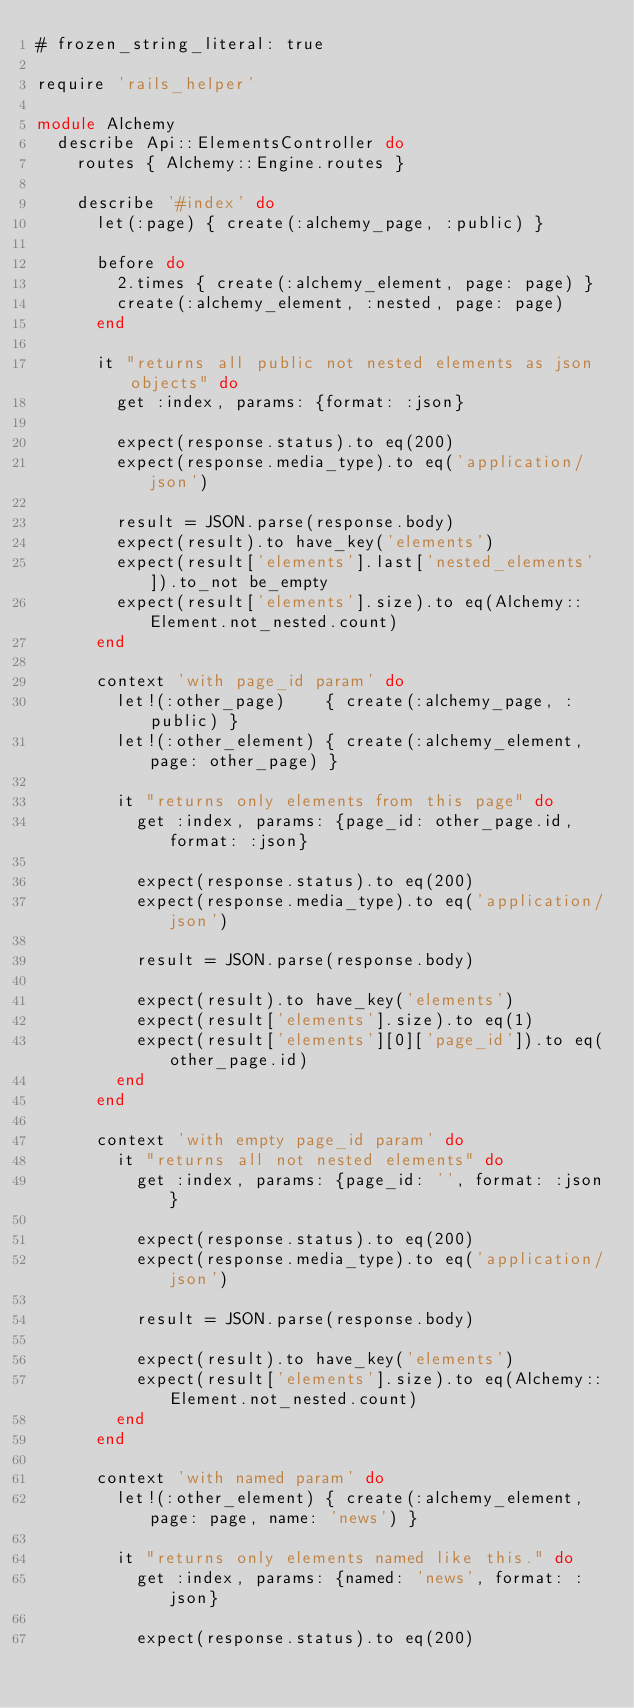Convert code to text. <code><loc_0><loc_0><loc_500><loc_500><_Ruby_># frozen_string_literal: true

require 'rails_helper'

module Alchemy
  describe Api::ElementsController do
    routes { Alchemy::Engine.routes }

    describe '#index' do
      let(:page) { create(:alchemy_page, :public) }

      before do
        2.times { create(:alchemy_element, page: page) }
        create(:alchemy_element, :nested, page: page)
      end

      it "returns all public not nested elements as json objects" do
        get :index, params: {format: :json}

        expect(response.status).to eq(200)
        expect(response.media_type).to eq('application/json')

        result = JSON.parse(response.body)
        expect(result).to have_key('elements')
        expect(result['elements'].last['nested_elements']).to_not be_empty
        expect(result['elements'].size).to eq(Alchemy::Element.not_nested.count)
      end

      context 'with page_id param' do
        let!(:other_page)    { create(:alchemy_page, :public) }
        let!(:other_element) { create(:alchemy_element, page: other_page) }

        it "returns only elements from this page" do
          get :index, params: {page_id: other_page.id, format: :json}

          expect(response.status).to eq(200)
          expect(response.media_type).to eq('application/json')

          result = JSON.parse(response.body)

          expect(result).to have_key('elements')
          expect(result['elements'].size).to eq(1)
          expect(result['elements'][0]['page_id']).to eq(other_page.id)
        end
      end

      context 'with empty page_id param' do
        it "returns all not nested elements" do
          get :index, params: {page_id: '', format: :json}

          expect(response.status).to eq(200)
          expect(response.media_type).to eq('application/json')

          result = JSON.parse(response.body)

          expect(result).to have_key('elements')
          expect(result['elements'].size).to eq(Alchemy::Element.not_nested.count)
        end
      end

      context 'with named param' do
        let!(:other_element) { create(:alchemy_element, page: page, name: 'news') }

        it "returns only elements named like this." do
          get :index, params: {named: 'news', format: :json}

          expect(response.status).to eq(200)</code> 